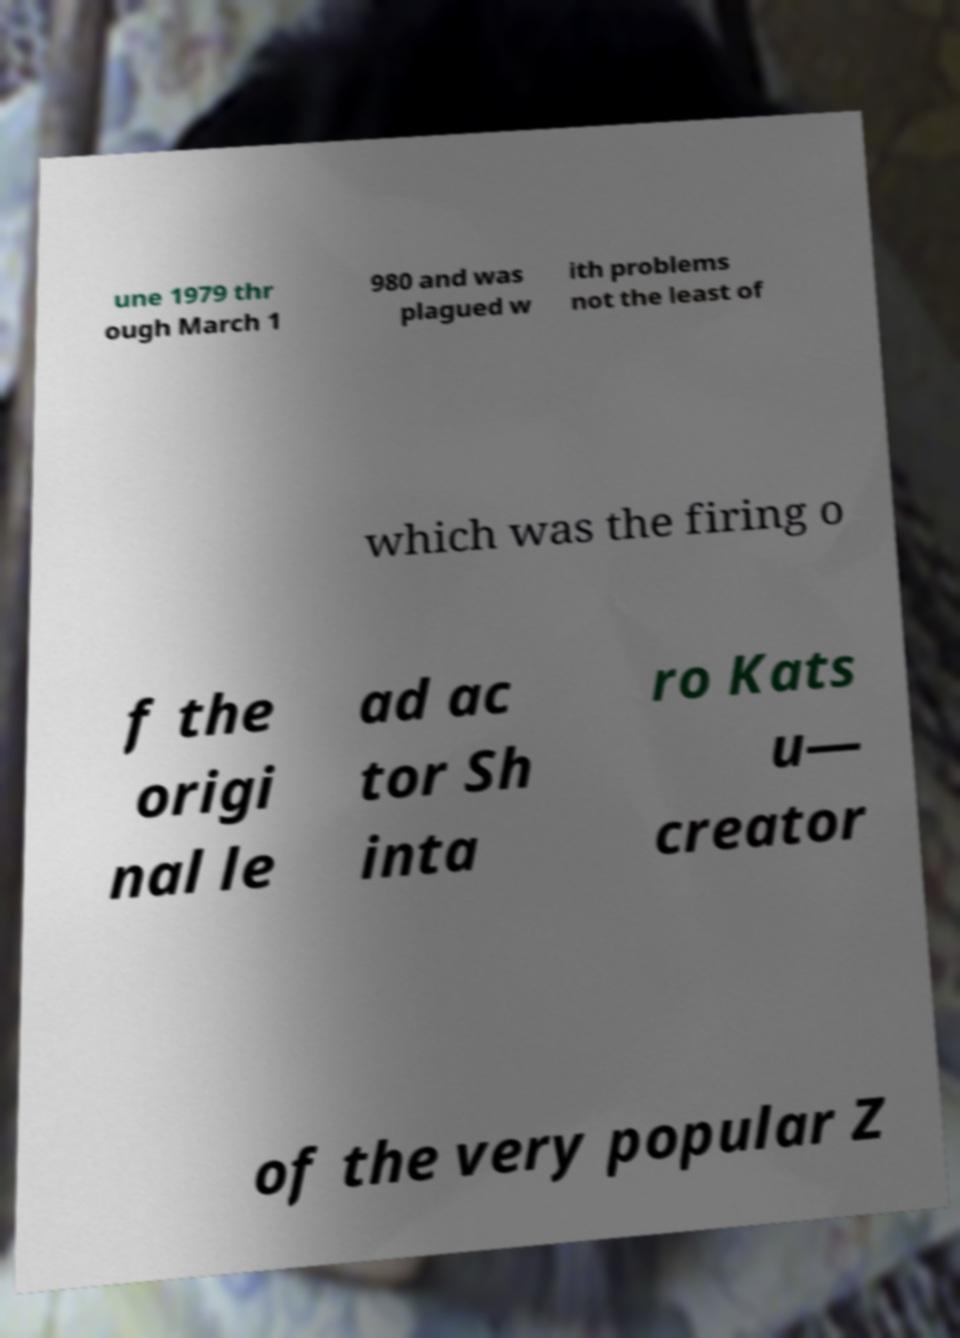Can you read and provide the text displayed in the image?This photo seems to have some interesting text. Can you extract and type it out for me? une 1979 thr ough March 1 980 and was plagued w ith problems not the least of which was the firing o f the origi nal le ad ac tor Sh inta ro Kats u— creator of the very popular Z 